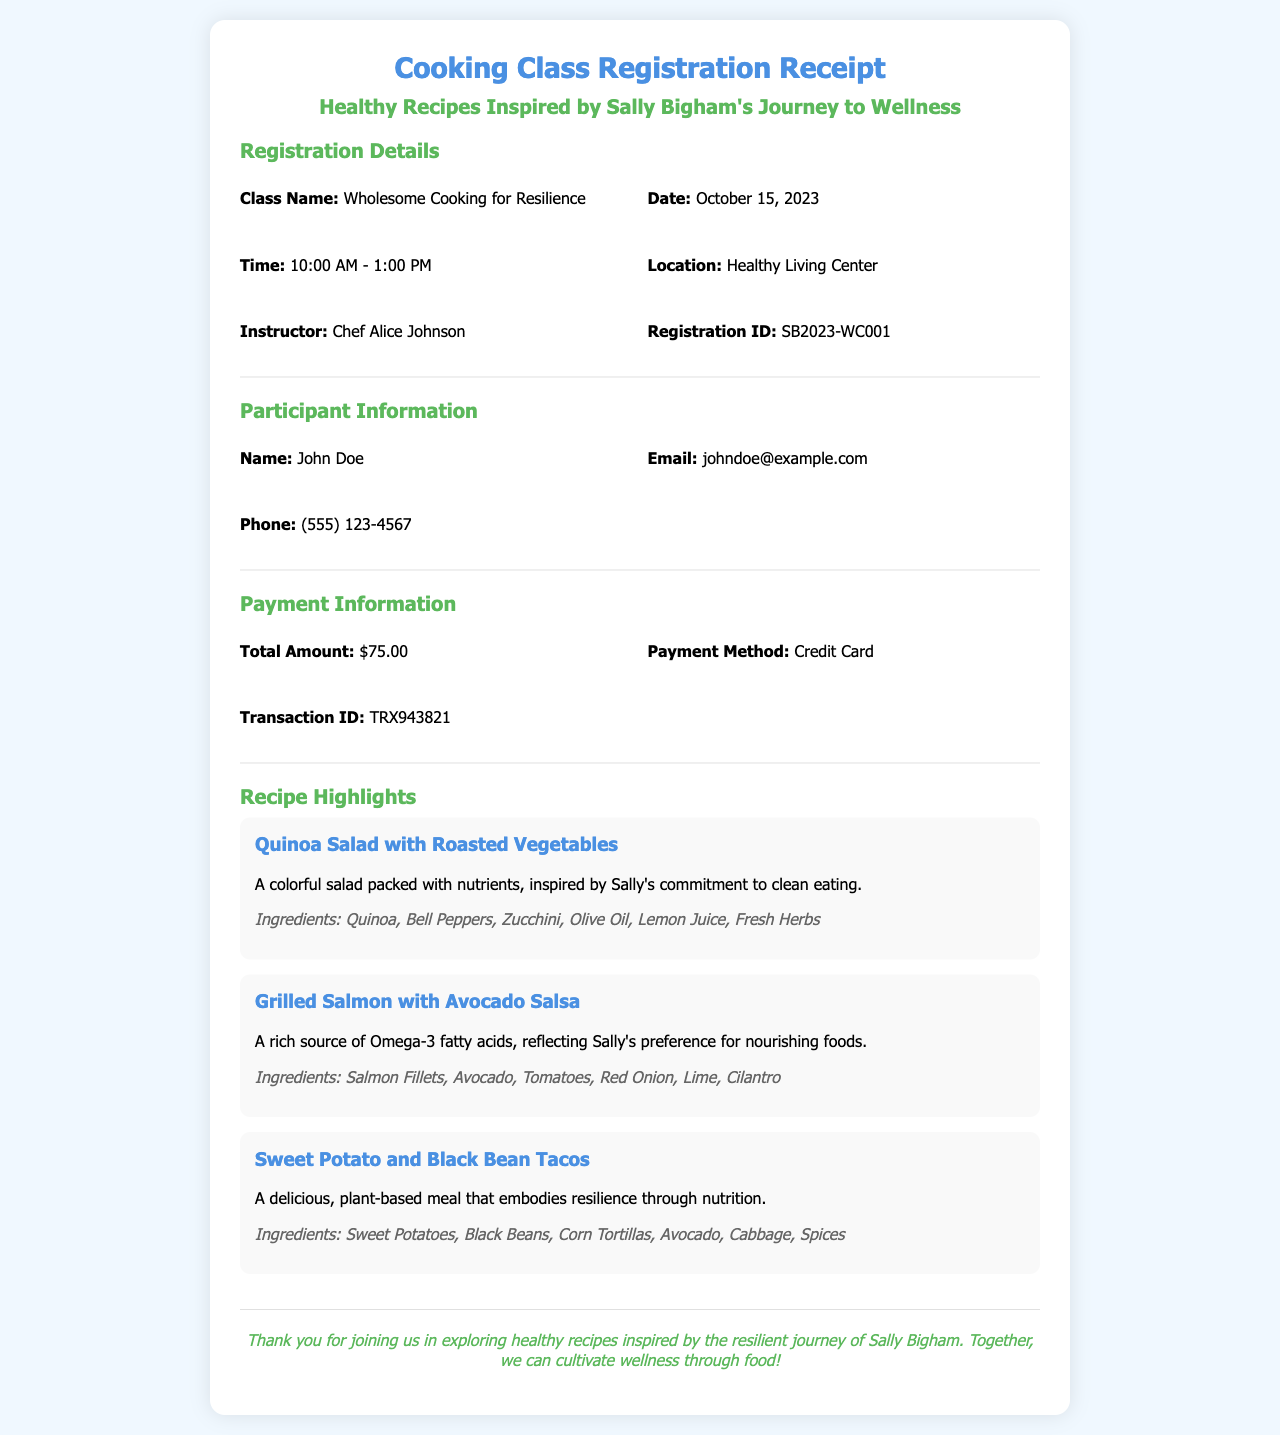What is the class name? The class name is stated in the registration details section of the receipt.
Answer: Wholesome Cooking for Resilience What date is the cooking class scheduled for? The class date is mentioned in the registration details section.
Answer: October 15, 2023 Who is the instructor for the class? The instructor's name is provided in the registration details section.
Answer: Chef Alice Johnson What is the total amount for the cooking class? The total amount is listed in the payment information section of the receipt.
Answer: $75.00 What is the email of the participant? The participant's email is found in the participant information section.
Answer: johndoe@example.com How long will the cooking class last? The duration can be inferred from the start and end times given in the registration details.
Answer: 3 hours What type of recipes are featured in the class? The type of recipes is described in the header and section titles of the receipt.
Answer: Healthy Recipes What ingredient is in the Quinoa Salad? The ingredients for the Quinoa Salad are listed in the recipe highlights section.
Answer: Quinoa What is the transaction ID for the registration? The transaction ID is provided in the payment information section.
Answer: TRX943821 What is the location of the cooking class? The location is mentioned in the registration details section.
Answer: Healthy Living Center 